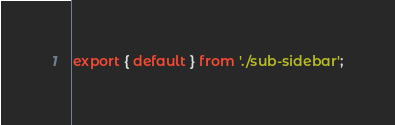Convert code to text. <code><loc_0><loc_0><loc_500><loc_500><_JavaScript_>export { default } from './sub-sidebar';
</code> 